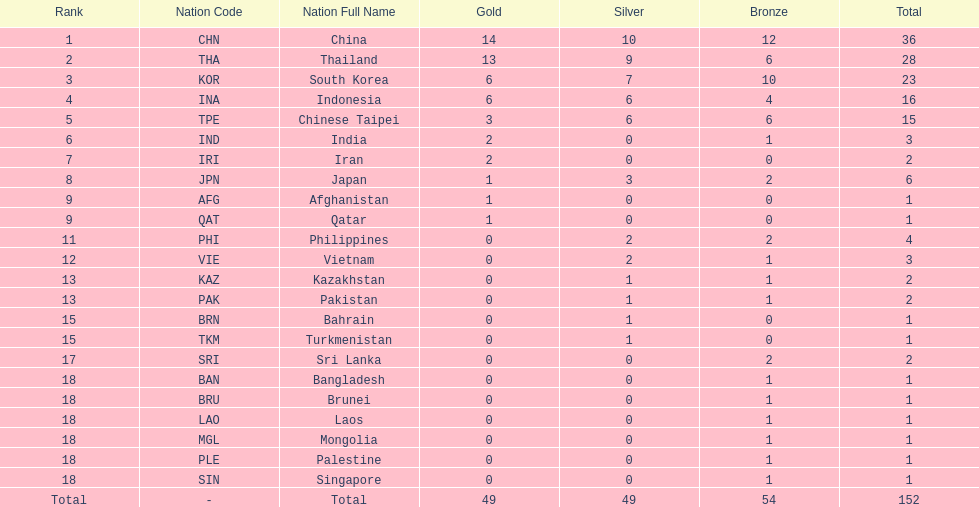Did the philippines or kazakhstan have a higher number of total medals? Philippines. Parse the full table. {'header': ['Rank', 'Nation Code', 'Nation Full Name', 'Gold', 'Silver', 'Bronze', 'Total'], 'rows': [['1', 'CHN', 'China', '14', '10', '12', '36'], ['2', 'THA', 'Thailand', '13', '9', '6', '28'], ['3', 'KOR', 'South Korea', '6', '7', '10', '23'], ['4', 'INA', 'Indonesia', '6', '6', '4', '16'], ['5', 'TPE', 'Chinese Taipei', '3', '6', '6', '15'], ['6', 'IND', 'India', '2', '0', '1', '3'], ['7', 'IRI', 'Iran', '2', '0', '0', '2'], ['8', 'JPN', 'Japan', '1', '3', '2', '6'], ['9', 'AFG', 'Afghanistan', '1', '0', '0', '1'], ['9', 'QAT', 'Qatar', '1', '0', '0', '1'], ['11', 'PHI', 'Philippines', '0', '2', '2', '4'], ['12', 'VIE', 'Vietnam', '0', '2', '1', '3'], ['13', 'KAZ', 'Kazakhstan', '0', '1', '1', '2'], ['13', 'PAK', 'Pakistan', '0', '1', '1', '2'], ['15', 'BRN', 'Bahrain', '0', '1', '0', '1'], ['15', 'TKM', 'Turkmenistan', '0', '1', '0', '1'], ['17', 'SRI', 'Sri Lanka', '0', '0', '2', '2'], ['18', 'BAN', 'Bangladesh', '0', '0', '1', '1'], ['18', 'BRU', 'Brunei', '0', '0', '1', '1'], ['18', 'LAO', 'Laos', '0', '0', '1', '1'], ['18', 'MGL', 'Mongolia', '0', '0', '1', '1'], ['18', 'PLE', 'Palestine', '0', '0', '1', '1'], ['18', 'SIN', 'Singapore', '0', '0', '1', '1'], ['Total', '-', 'Total', '49', '49', '54', '152']]} 